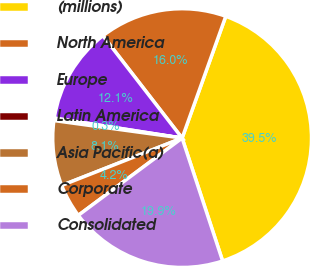Convert chart to OTSL. <chart><loc_0><loc_0><loc_500><loc_500><pie_chart><fcel>(millions)<fcel>North America<fcel>Europe<fcel>Latin America<fcel>Asia Pacific(a)<fcel>Corporate<fcel>Consolidated<nl><fcel>39.45%<fcel>15.96%<fcel>12.05%<fcel>0.3%<fcel>8.13%<fcel>4.22%<fcel>19.88%<nl></chart> 